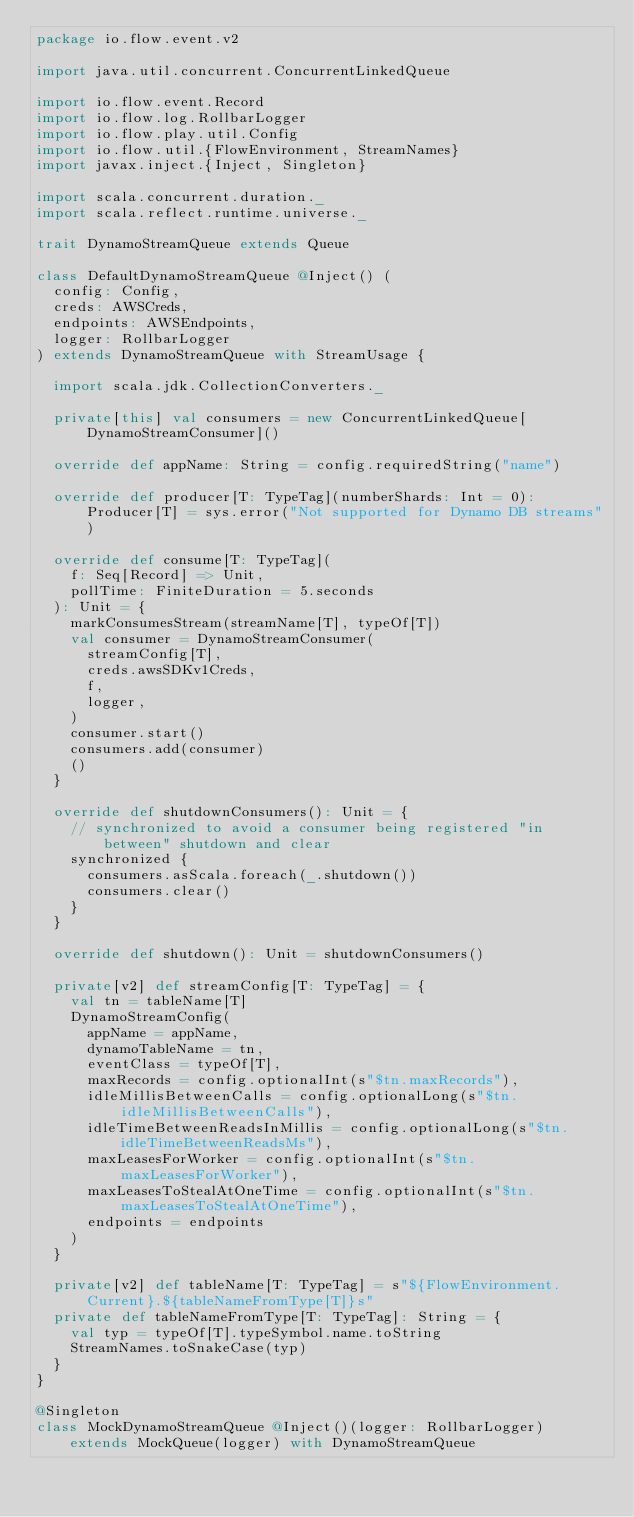Convert code to text. <code><loc_0><loc_0><loc_500><loc_500><_Scala_>package io.flow.event.v2

import java.util.concurrent.ConcurrentLinkedQueue

import io.flow.event.Record
import io.flow.log.RollbarLogger
import io.flow.play.util.Config
import io.flow.util.{FlowEnvironment, StreamNames}
import javax.inject.{Inject, Singleton}

import scala.concurrent.duration._
import scala.reflect.runtime.universe._

trait DynamoStreamQueue extends Queue

class DefaultDynamoStreamQueue @Inject() (
  config: Config,
  creds: AWSCreds,
  endpoints: AWSEndpoints,
  logger: RollbarLogger
) extends DynamoStreamQueue with StreamUsage {

  import scala.jdk.CollectionConverters._

  private[this] val consumers = new ConcurrentLinkedQueue[DynamoStreamConsumer]()

  override def appName: String = config.requiredString("name")

  override def producer[T: TypeTag](numberShards: Int = 0): Producer[T] = sys.error("Not supported for Dynamo DB streams")

  override def consume[T: TypeTag](
    f: Seq[Record] => Unit,
    pollTime: FiniteDuration = 5.seconds
  ): Unit = {
    markConsumesStream(streamName[T], typeOf[T])
    val consumer = DynamoStreamConsumer(
      streamConfig[T],
      creds.awsSDKv1Creds,
      f,
      logger,
    )
    consumer.start()
    consumers.add(consumer)
    ()
  }

  override def shutdownConsumers(): Unit = {
    // synchronized to avoid a consumer being registered "in between" shutdown and clear
    synchronized {
      consumers.asScala.foreach(_.shutdown())
      consumers.clear()
    }
  }

  override def shutdown(): Unit = shutdownConsumers()

  private[v2] def streamConfig[T: TypeTag] = {
    val tn = tableName[T]
    DynamoStreamConfig(
      appName = appName,
      dynamoTableName = tn,
      eventClass = typeOf[T],
      maxRecords = config.optionalInt(s"$tn.maxRecords"),
      idleMillisBetweenCalls = config.optionalLong(s"$tn.idleMillisBetweenCalls"),
      idleTimeBetweenReadsInMillis = config.optionalLong(s"$tn.idleTimeBetweenReadsMs"),
      maxLeasesForWorker = config.optionalInt(s"$tn.maxLeasesForWorker"),
      maxLeasesToStealAtOneTime = config.optionalInt(s"$tn.maxLeasesToStealAtOneTime"),
      endpoints = endpoints
    )
  }

  private[v2] def tableName[T: TypeTag] = s"${FlowEnvironment.Current}.${tableNameFromType[T]}s"
  private def tableNameFromType[T: TypeTag]: String = {
    val typ = typeOf[T].typeSymbol.name.toString
    StreamNames.toSnakeCase(typ)
  }
}

@Singleton
class MockDynamoStreamQueue @Inject()(logger: RollbarLogger) extends MockQueue(logger) with DynamoStreamQueue
</code> 